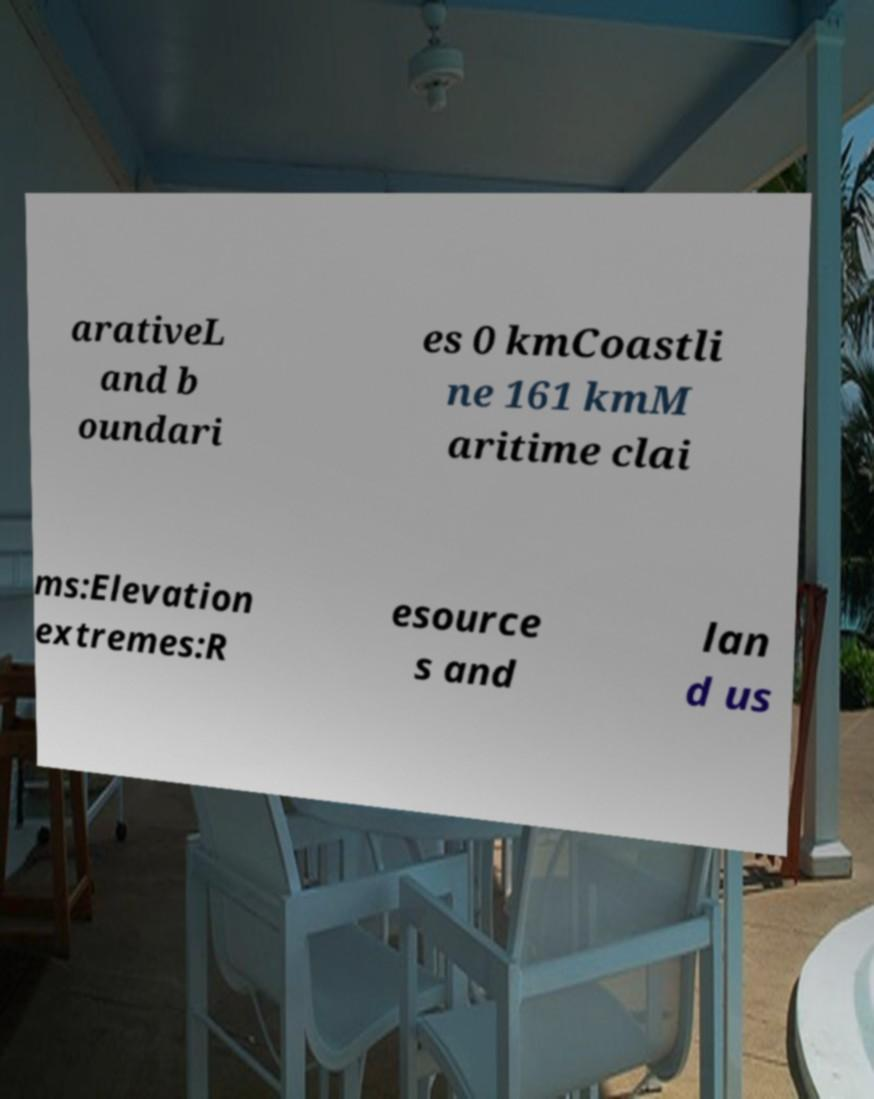Could you extract and type out the text from this image? arativeL and b oundari es 0 kmCoastli ne 161 kmM aritime clai ms:Elevation extremes:R esource s and lan d us 